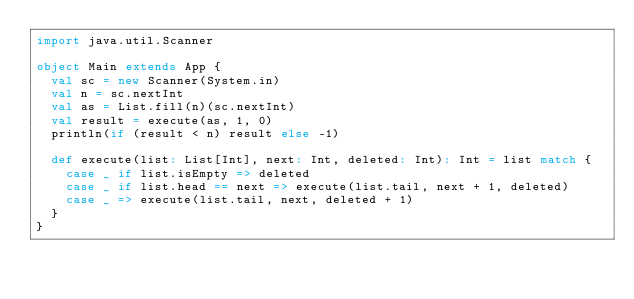<code> <loc_0><loc_0><loc_500><loc_500><_Scala_>import java.util.Scanner

object Main extends App {
  val sc = new Scanner(System.in)
  val n = sc.nextInt
  val as = List.fill(n)(sc.nextInt)
  val result = execute(as, 1, 0)
  println(if (result < n) result else -1)

  def execute(list: List[Int], next: Int, deleted: Int): Int = list match {
    case _ if list.isEmpty => deleted
    case _ if list.head == next => execute(list.tail, next + 1, deleted)
    case _ => execute(list.tail, next, deleted + 1)
  }
}
</code> 